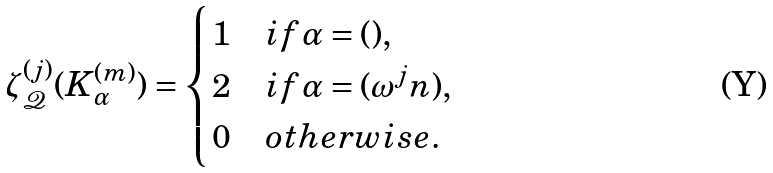<formula> <loc_0><loc_0><loc_500><loc_500>\zeta ^ { ( j ) } _ { \mathcal { Q } } ( K ^ { ( m ) } _ { \alpha } ) = \begin{cases} 1 & i f \alpha = ( ) , \\ 2 & i f \alpha = ( \omega ^ { j } n ) , \\ 0 & o t h e r w i s e . \end{cases}</formula> 